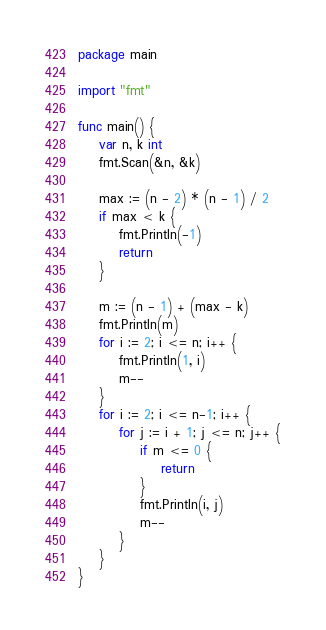<code> <loc_0><loc_0><loc_500><loc_500><_Go_>package main

import "fmt"

func main() {
	var n, k int
	fmt.Scan(&n, &k)

	max := (n - 2) * (n - 1) / 2
	if max < k {
		fmt.Println(-1)
		return
	}

	m := (n - 1) + (max - k)
	fmt.Println(m)
	for i := 2; i <= n; i++ {
		fmt.Println(1, i)
		m--
	}
	for i := 2; i <= n-1; i++ {
		for j := i + 1; j <= n; j++ {
			if m <= 0 {
				return
			}
			fmt.Println(i, j)
			m--
		}
	}
}
</code> 